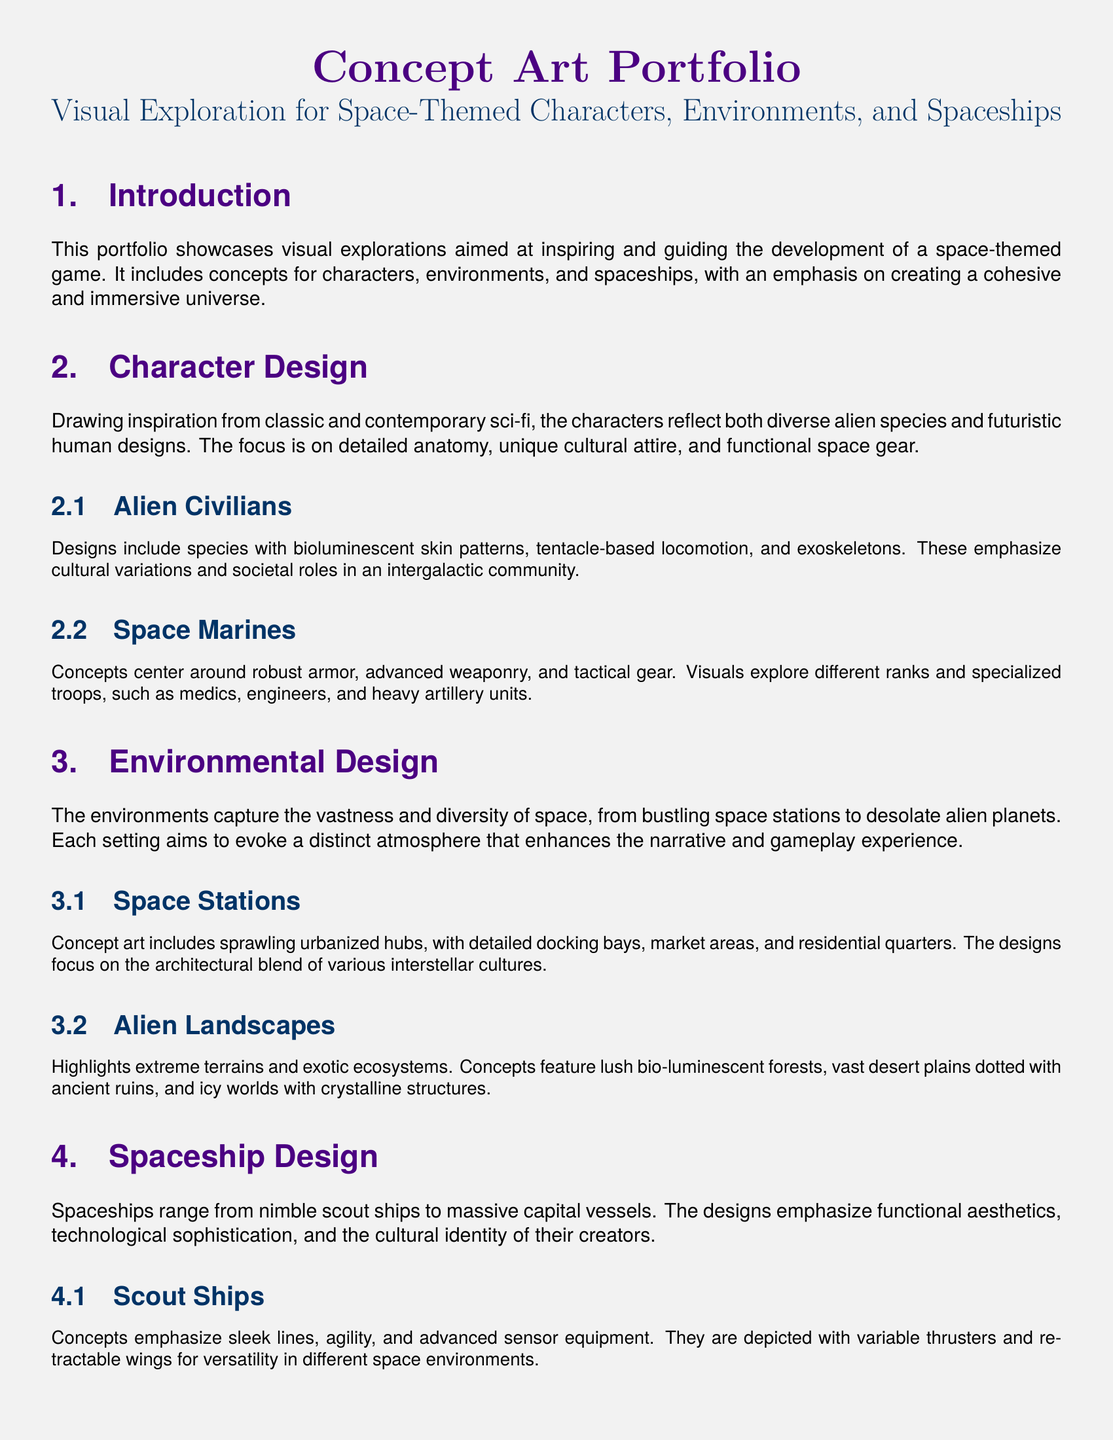what is the title of the portfolio? The title is stated prominently at the beginning of the document.
Answer: Concept Art Portfolio how many sections are there in the document? The document includes several clearly defined sections, which can be counted.
Answer: 5 what unique feature is emphasized in the design of alien civilians? The process mentions specific attributes that characterize the design of alien civilians.
Answer: Bioluminescent skin patterns what types of spaceships are discussed in the document? The document lists different categories of spaceships, indicating their distinctions.
Answer: Scout Ships and Capital Ships what is the focus of the environmental design section? The section outlines the primary goal of environmental design in the context of a space-themed game.
Answer: Evoking distinct atmosphere which colors are used in the title formatting? The formatting specifies the colors associated with the section titles.
Answer: Spacepurple and Spaceblue what aspect of the space marines is highlighted? The document mentions specific attributes that define the space marines visually.
Answer: Advanced weaponry what type of terrain is featured in alien landscapes? The document describes various environmental features prominently within the alien landscapes section.
Answer: Extreme terrains 